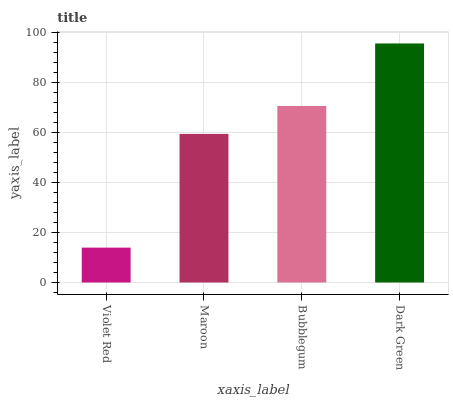Is Maroon the minimum?
Answer yes or no. No. Is Maroon the maximum?
Answer yes or no. No. Is Maroon greater than Violet Red?
Answer yes or no. Yes. Is Violet Red less than Maroon?
Answer yes or no. Yes. Is Violet Red greater than Maroon?
Answer yes or no. No. Is Maroon less than Violet Red?
Answer yes or no. No. Is Bubblegum the high median?
Answer yes or no. Yes. Is Maroon the low median?
Answer yes or no. Yes. Is Dark Green the high median?
Answer yes or no. No. Is Violet Red the low median?
Answer yes or no. No. 